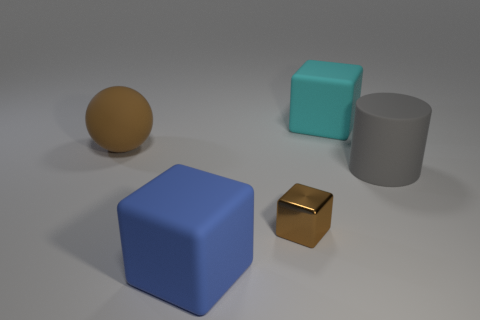Is there anything else that has the same material as the cylinder?
Offer a terse response. Yes. What size is the blue rubber thing that is the same shape as the cyan rubber object?
Provide a succinct answer. Large. The big thing that is both to the left of the tiny brown block and to the right of the rubber sphere is what color?
Provide a short and direct response. Blue. Is the material of the big blue thing the same as the large block behind the brown metallic cube?
Ensure brevity in your answer.  Yes. Is the number of small brown shiny things that are on the left side of the large rubber sphere less than the number of big yellow metal objects?
Provide a succinct answer. No. What number of other objects are the same shape as the large gray matte thing?
Your answer should be compact. 0. Is there any other thing that is the same color as the small thing?
Make the answer very short. Yes. Is the color of the small metallic cube the same as the matte cube to the right of the tiny block?
Offer a very short reply. No. How many other things are there of the same size as the metal block?
Ensure brevity in your answer.  0. What is the size of the shiny object that is the same color as the big sphere?
Keep it short and to the point. Small. 